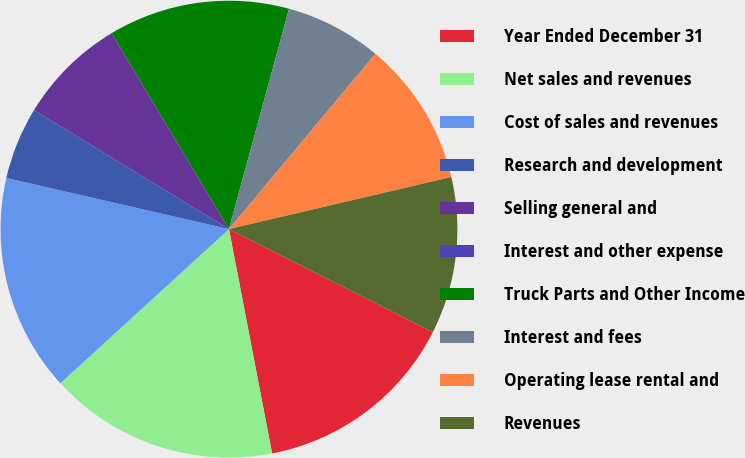Convert chart to OTSL. <chart><loc_0><loc_0><loc_500><loc_500><pie_chart><fcel>Year Ended December 31<fcel>Net sales and revenues<fcel>Cost of sales and revenues<fcel>Research and development<fcel>Selling general and<fcel>Interest and other expense<fcel>Truck Parts and Other Income<fcel>Interest and fees<fcel>Operating lease rental and<fcel>Revenues<nl><fcel>14.53%<fcel>16.24%<fcel>15.38%<fcel>5.13%<fcel>7.69%<fcel>0.0%<fcel>12.82%<fcel>6.84%<fcel>10.26%<fcel>11.11%<nl></chart> 